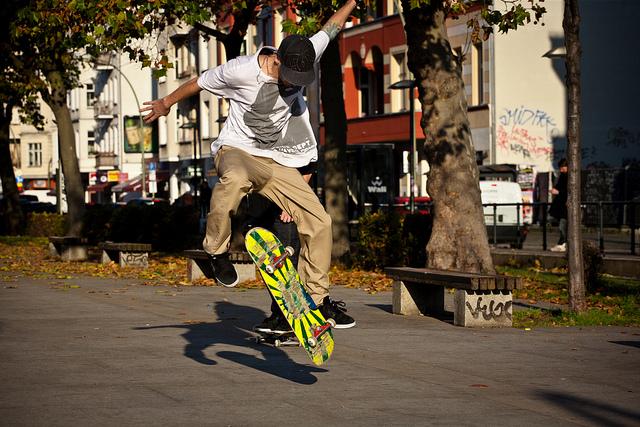Is this a busy city?
Give a very brief answer. No. Is there more than one instance of graffiti?
Short answer required. Yes. Is it a sunny day?
Be succinct. Yes. Is he wearing a long pant?
Answer briefly. Yes. Is it safe to cross the street?
Keep it brief. Yes. 